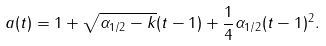Convert formula to latex. <formula><loc_0><loc_0><loc_500><loc_500>a ( t ) = 1 + \sqrt { \alpha _ { 1 / 2 } - k } ( t - 1 ) + \frac { 1 } { 4 } \alpha _ { 1 / 2 } ( t - 1 ) ^ { 2 } .</formula> 